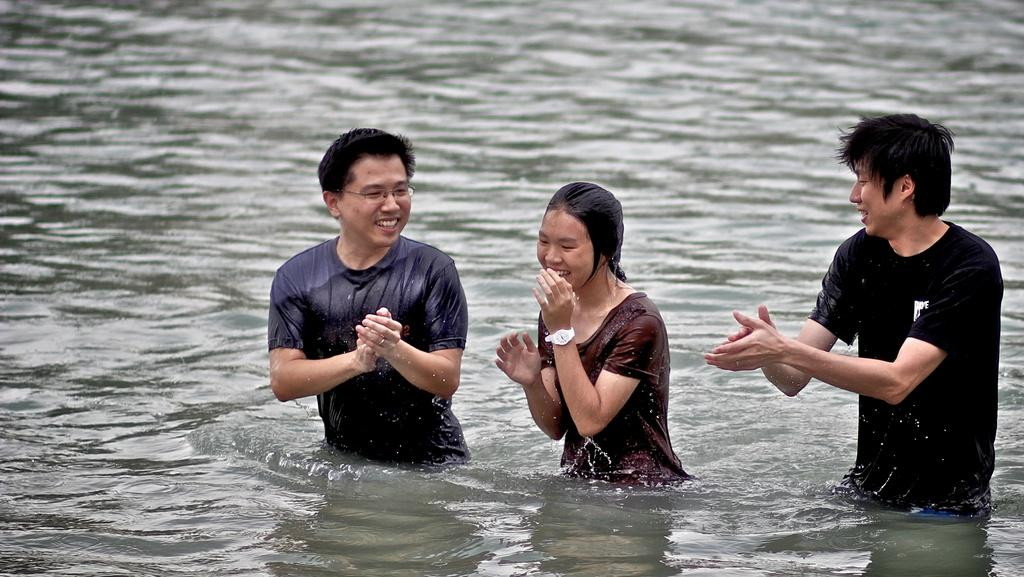How many people are in the image? There are three persons in the image. What are the people in the image doing? The three persons are standing in the water. What type of circle can be seen in the image? There is no circle present in the image; it features three persons standing in the water. What kind of pies are being eaten by the persons in the image? There is no indication of any pies being eaten in the image; the persons are standing in the water. 